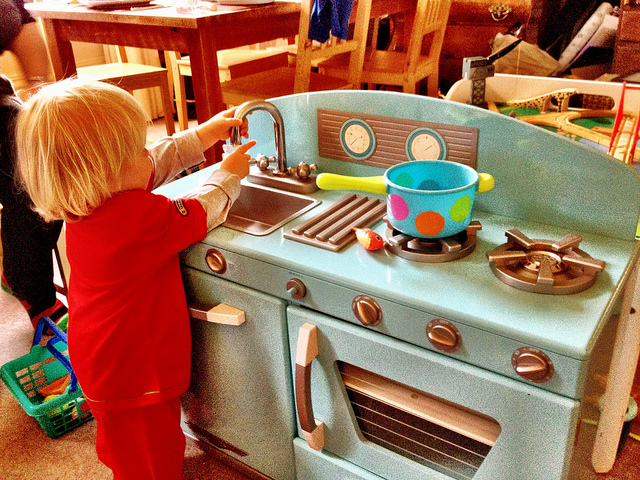What will come out of the sink?
A. gasoline
B. soda
C. water
D. nothing
Answer with the option's letter from the given choices directly. Although it's a playful scenario, given the context that the sink is part of a toy kitchen and appears to be non-functional, the most accurate answer is D, implying that nothing would come out of this particular toy sink. 